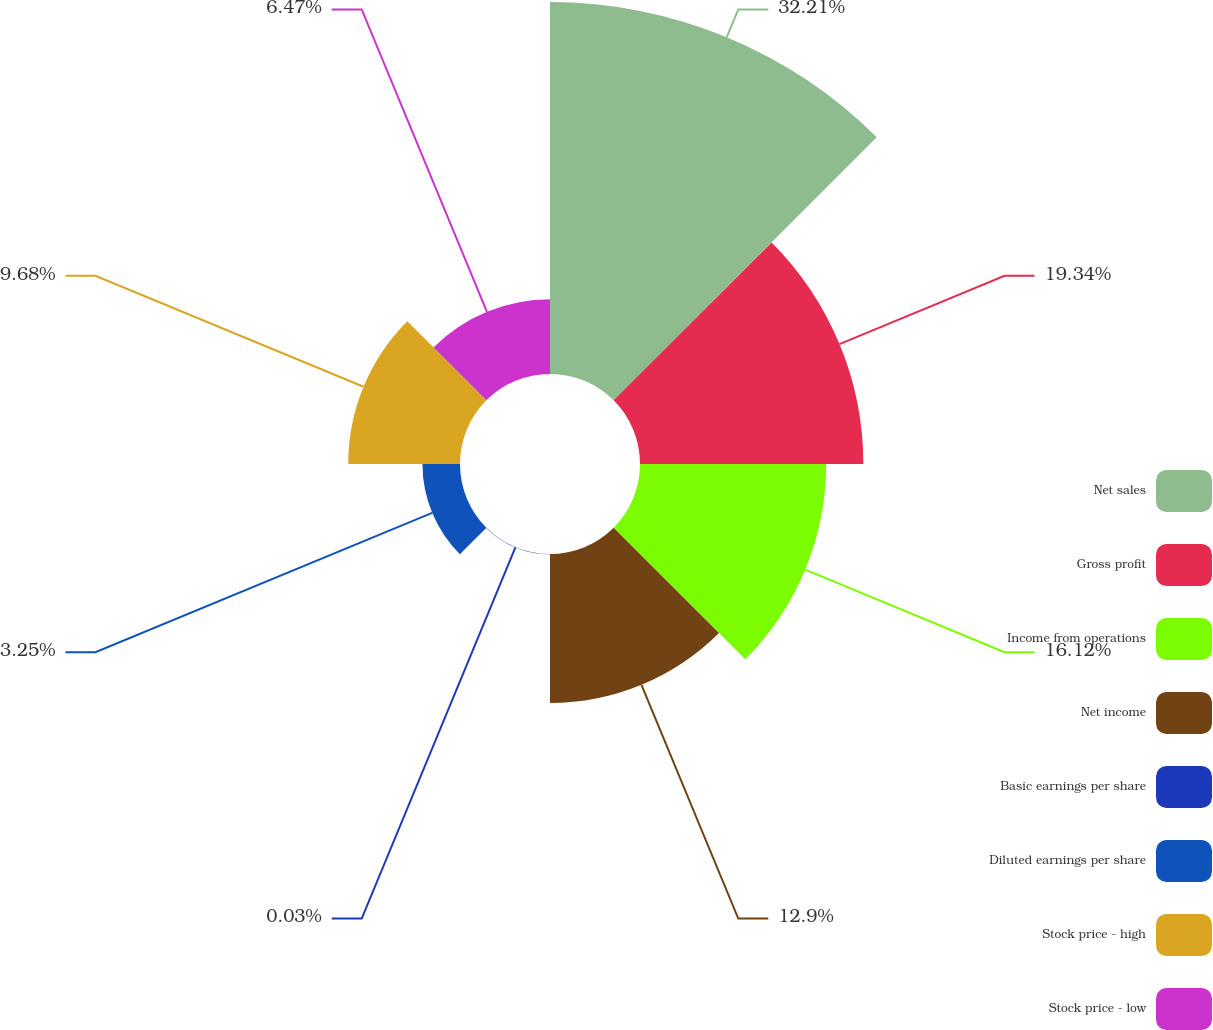Convert chart to OTSL. <chart><loc_0><loc_0><loc_500><loc_500><pie_chart><fcel>Net sales<fcel>Gross profit<fcel>Income from operations<fcel>Net income<fcel>Basic earnings per share<fcel>Diluted earnings per share<fcel>Stock price - high<fcel>Stock price - low<nl><fcel>32.21%<fcel>19.34%<fcel>16.12%<fcel>12.9%<fcel>0.03%<fcel>3.25%<fcel>9.68%<fcel>6.47%<nl></chart> 